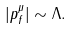Convert formula to latex. <formula><loc_0><loc_0><loc_500><loc_500>| p _ { f } ^ { \mu } | \sim \Lambda .</formula> 